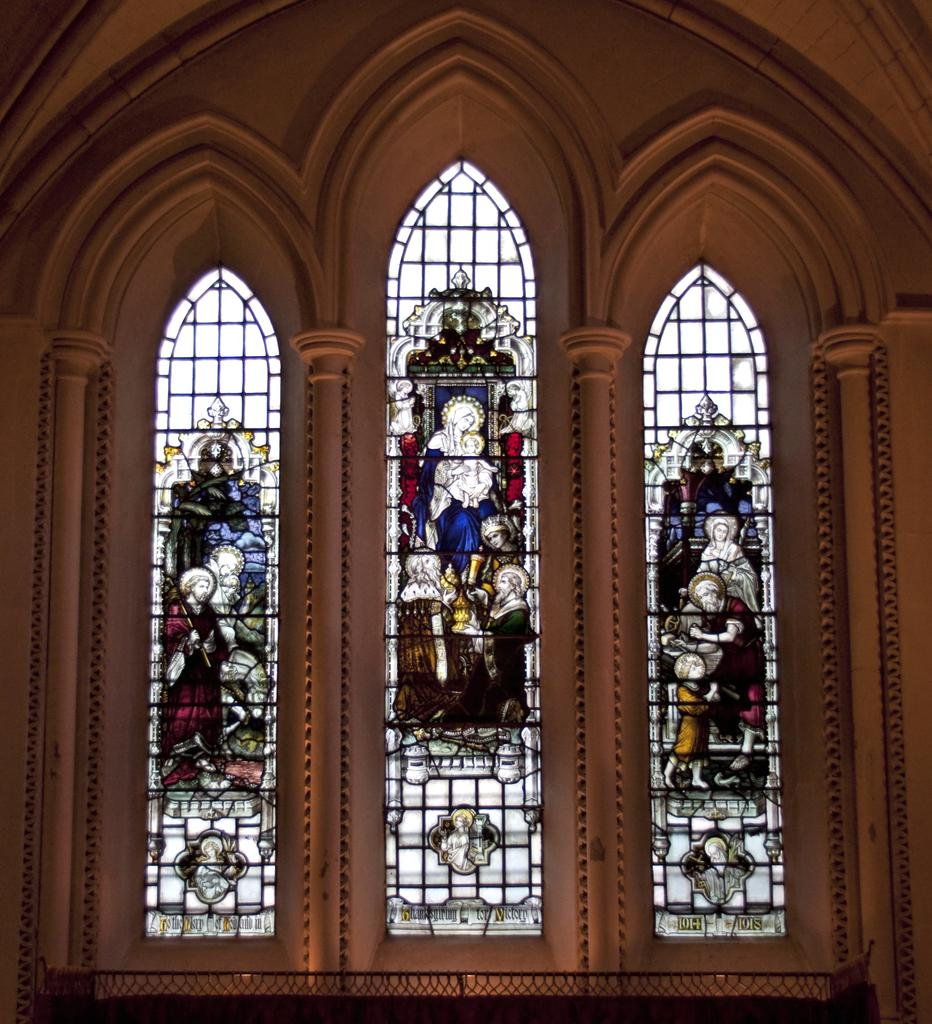What type of location is depicted in the image? The image shows the interior of a place. What feature can be seen on the windows in the image? The windows have different images on them. How many windows are visible in the image? The number of windows is not specified, but there are many pillars in the image. What can be inferred about the lighting in the location? The presence of large windows made of glass suggests that the location may receive ample natural light. What type of engine is visible in the image? There is no engine present in the image. How does the loss of nut affect the image? There is no mention of a nut or its loss in the image, so it is not possible to determine any effect. 